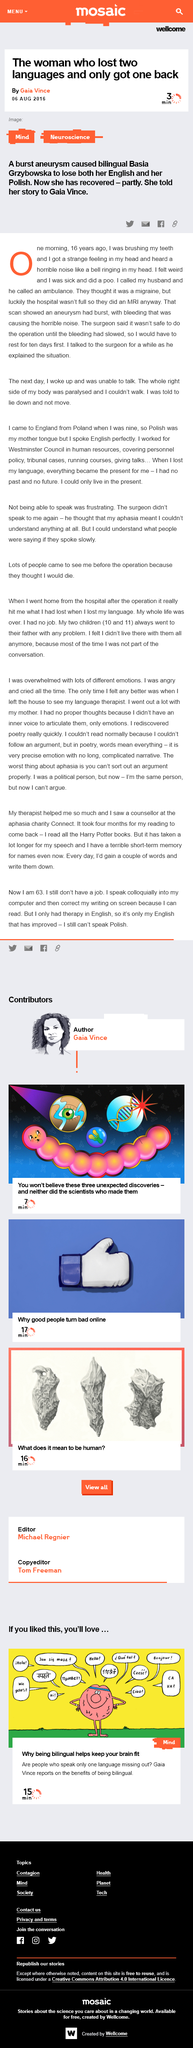Outline some significant characteristics in this image. The event occurred 16 years ago. The transformation from migraine symptoms to paralysis occurred overnight, and the individual's mobility was completely impaired. The initial diagnosis was a migraine. It is impossible for this person to speak Polish at this time. The person's reading took four months to return after it had been checked. 